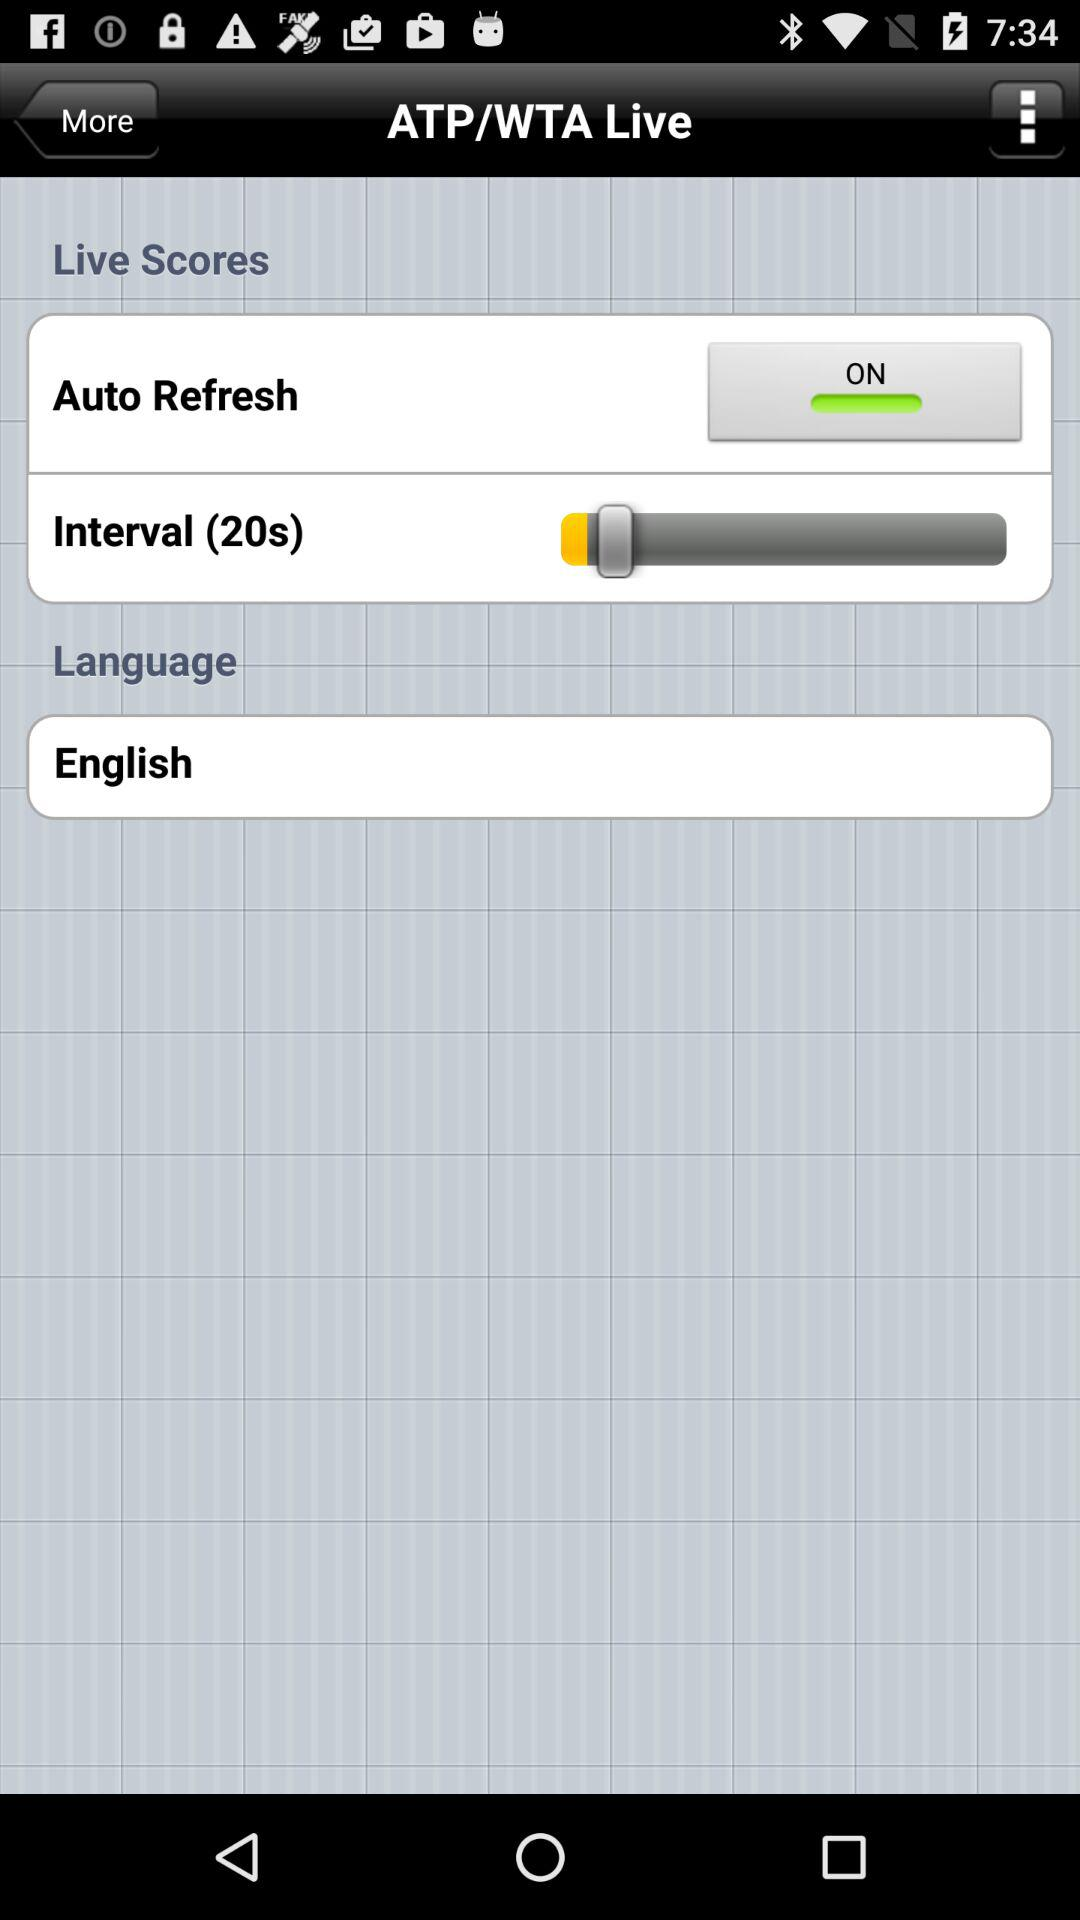How many seconds is the interval set to?
Answer the question using a single word or phrase. 20 